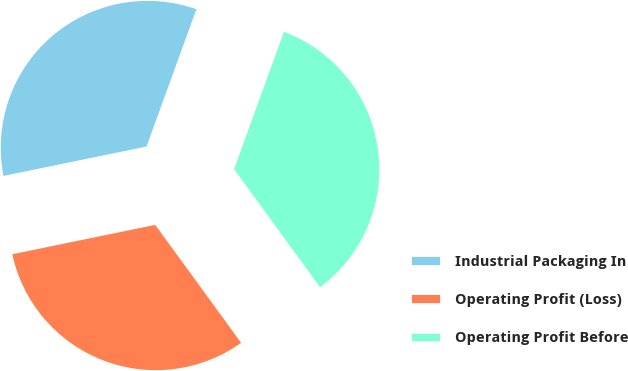<chart> <loc_0><loc_0><loc_500><loc_500><pie_chart><fcel>Industrial Packaging In<fcel>Operating Profit (Loss)<fcel>Operating Profit Before<nl><fcel>33.77%<fcel>31.79%<fcel>34.44%<nl></chart> 